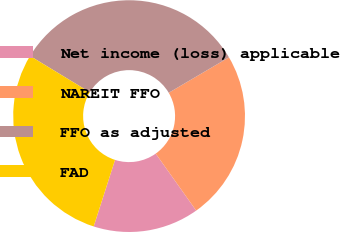<chart> <loc_0><loc_0><loc_500><loc_500><pie_chart><fcel>Net income (loss) applicable<fcel>NAREIT FFO<fcel>FFO as adjusted<fcel>FAD<nl><fcel>14.77%<fcel>23.64%<fcel>32.84%<fcel>28.74%<nl></chart> 